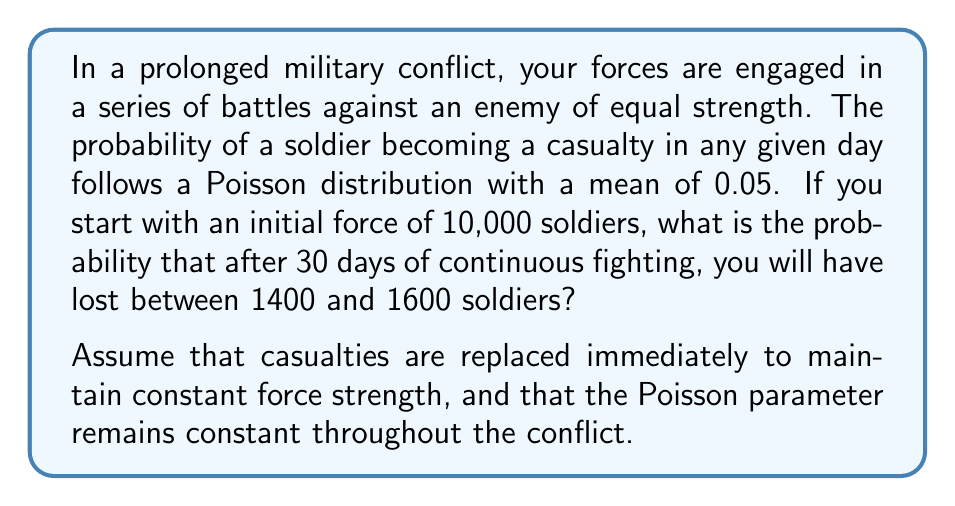Provide a solution to this math problem. To solve this problem, we need to use the properties of the Poisson distribution and its relationship to the normal distribution for large numbers. Let's break it down step-by-step:

1) First, we need to calculate the expected number of casualties over 30 days:
   $$\lambda = 10000 \times 30 \times 0.05 = 15000$$

2) For large $\lambda$ (typically $\lambda > 30$), the Poisson distribution can be approximated by a normal distribution with mean $\mu = \lambda$ and standard deviation $\sigma = \sqrt{\lambda}$.

3) In this case:
   $$\mu = 15000$$
   $$\sigma = \sqrt{15000} \approx 122.47$$

4) We want to find the probability of losing between 1400 and 1600 soldiers. We can standardize these values:
   $$z_1 = \frac{1400 - 15000}{122.47} \approx -111.05$$
   $$z_2 = \frac{1600 - 15000}{122.47} \approx -109.41$$

5) The probability we're looking for is equivalent to the area under the standard normal curve between $z_1$ and $z_2$:
   $$P(1400 < X < 1600) = \Phi(z_2) - \Phi(z_1)$$

   Where $\Phi(z)$ is the cumulative distribution function of the standard normal distribution.

6) Using a standard normal table or calculator:
   $$\Phi(-109.41) \approx 0$$
   $$\Phi(-111.05) \approx 0$$

7) Therefore:
   $$P(1400 < X < 1600) = 0 - 0 = 0$$

The probability is effectively zero because the expected number of casualties (15000) is so much larger than the range we're considering (1400-1600).
Answer: The probability of losing between 1400 and 1600 soldiers after 30 days is effectively 0. 